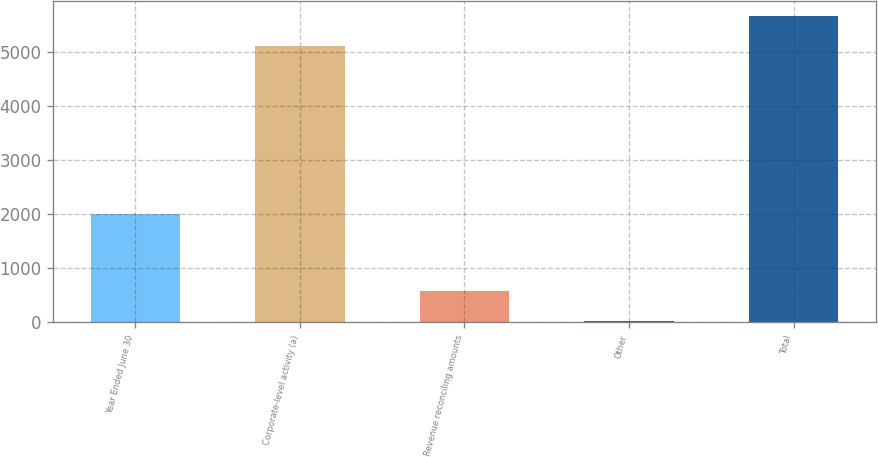Convert chart. <chart><loc_0><loc_0><loc_500><loc_500><bar_chart><fcel>Year Ended June 30<fcel>Corporate-level activity (a)<fcel>Revenue reconciling amounts<fcel>Other<fcel>Total<nl><fcel>2012<fcel>5114<fcel>586.2<fcel>33<fcel>5667.2<nl></chart> 